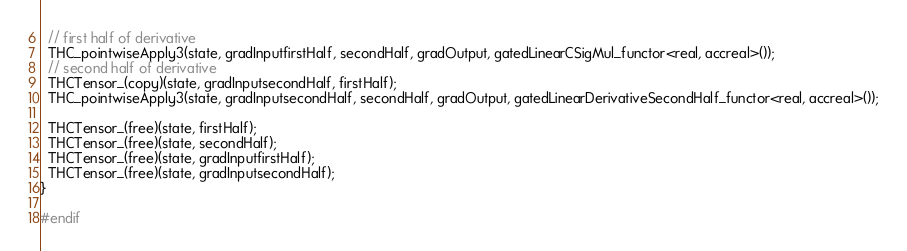Convert code to text. <code><loc_0><loc_0><loc_500><loc_500><_Cuda_>  // first half of derivative
  THC_pointwiseApply3(state, gradInputfirstHalf, secondHalf, gradOutput, gatedLinearCSigMul_functor<real, accreal>());
  // second half of derivative
  THCTensor_(copy)(state, gradInputsecondHalf, firstHalf);
  THC_pointwiseApply3(state, gradInputsecondHalf, secondHalf, gradOutput, gatedLinearDerivativeSecondHalf_functor<real, accreal>());

  THCTensor_(free)(state, firstHalf);
  THCTensor_(free)(state, secondHalf);
  THCTensor_(free)(state, gradInputfirstHalf);
  THCTensor_(free)(state, gradInputsecondHalf);
}

#endif</code> 